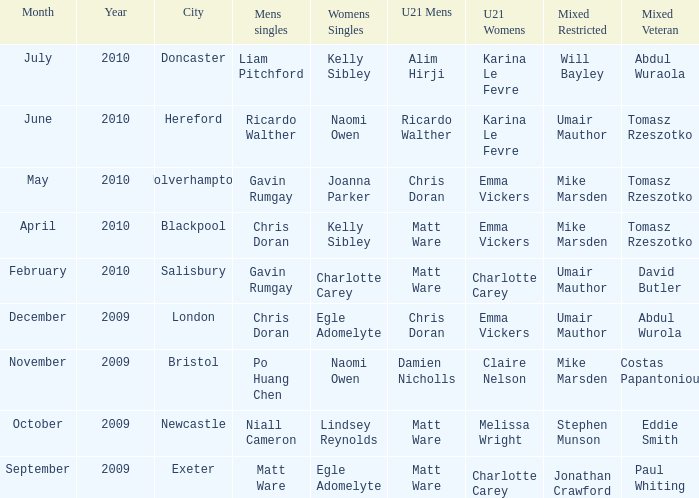Who won the mixed restricted when Tomasz Rzeszotko won the mixed veteran and Karina Le Fevre won the U21 womens? Umair Mauthor. 